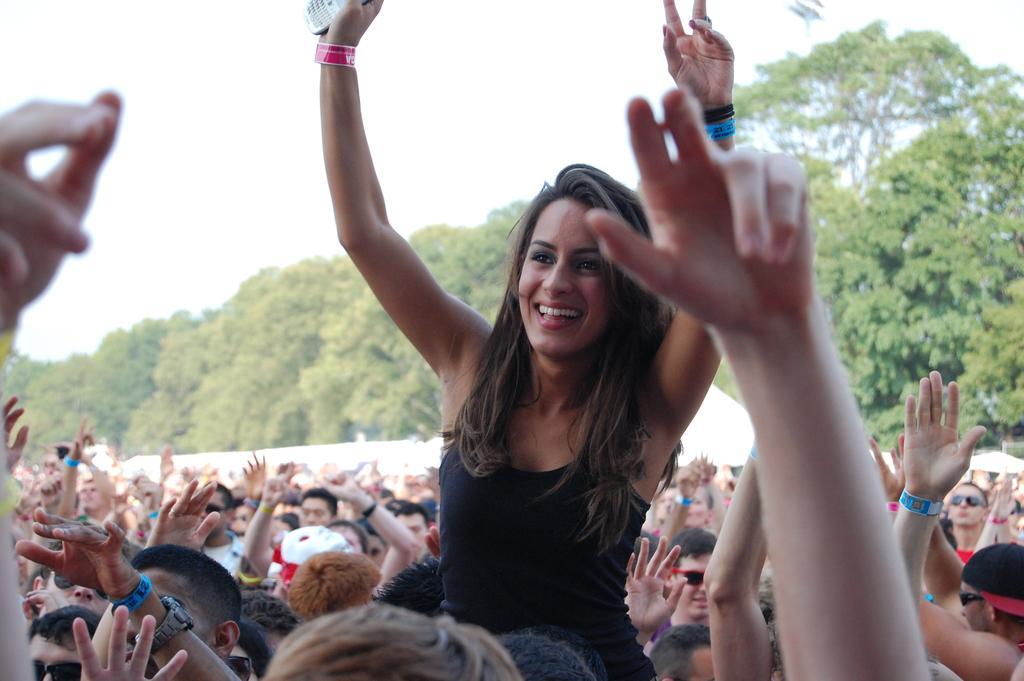Describe this image in one or two sentences. In the front of the image I can see crowd, among them a woman is holding a mobile and smiling. In the background of the image there are trees and sky.   